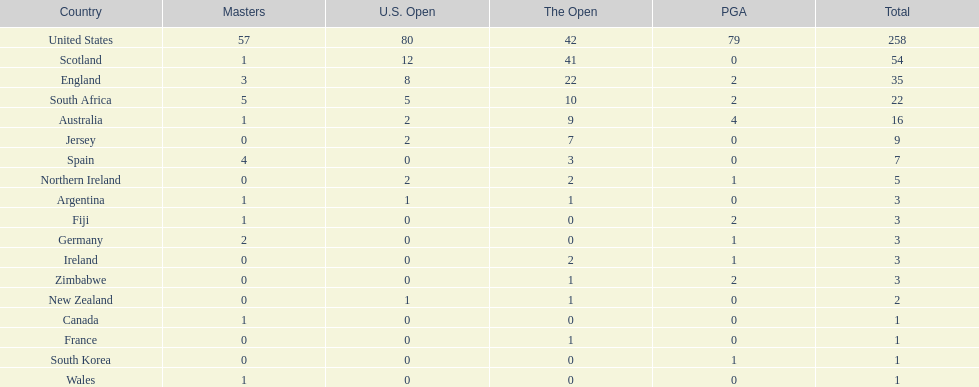Could you help me parse every detail presented in this table? {'header': ['Country', 'Masters', 'U.S. Open', 'The Open', 'PGA', 'Total'], 'rows': [['United States', '57', '80', '42', '79', '258'], ['Scotland', '1', '12', '41', '0', '54'], ['England', '3', '8', '22', '2', '35'], ['South Africa', '5', '5', '10', '2', '22'], ['Australia', '1', '2', '9', '4', '16'], ['Jersey', '0', '2', '7', '0', '9'], ['Spain', '4', '0', '3', '0', '7'], ['Northern Ireland', '0', '2', '2', '1', '5'], ['Argentina', '1', '1', '1', '0', '3'], ['Fiji', '1', '0', '0', '2', '3'], ['Germany', '2', '0', '0', '1', '3'], ['Ireland', '0', '0', '2', '1', '3'], ['Zimbabwe', '0', '0', '1', '2', '3'], ['New Zealand', '0', '1', '1', '0', '2'], ['Canada', '1', '0', '0', '0', '1'], ['France', '0', '0', '1', '0', '1'], ['South Korea', '0', '0', '0', '1', '1'], ['Wales', '1', '0', '0', '0', '1']]} How many countries have generated an identical number of championship golfers as canada? 3. 